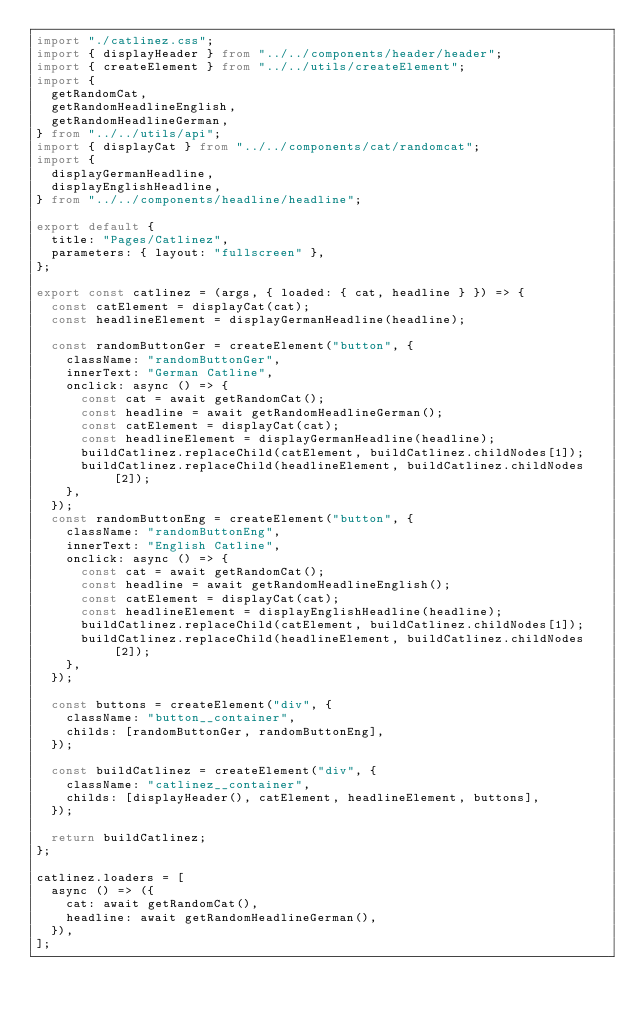Convert code to text. <code><loc_0><loc_0><loc_500><loc_500><_TypeScript_>import "./catlinez.css";
import { displayHeader } from "../../components/header/header";
import { createElement } from "../../utils/createElement";
import {
  getRandomCat,
  getRandomHeadlineEnglish,
  getRandomHeadlineGerman,
} from "../../utils/api";
import { displayCat } from "../../components/cat/randomcat";
import {
  displayGermanHeadline,
  displayEnglishHeadline,
} from "../../components/headline/headline";

export default {
  title: "Pages/Catlinez",
  parameters: { layout: "fullscreen" },
};

export const catlinez = (args, { loaded: { cat, headline } }) => {
  const catElement = displayCat(cat);
  const headlineElement = displayGermanHeadline(headline);

  const randomButtonGer = createElement("button", {
    className: "randomButtonGer",
    innerText: "German Catline",
    onclick: async () => {
      const cat = await getRandomCat();
      const headline = await getRandomHeadlineGerman();
      const catElement = displayCat(cat);
      const headlineElement = displayGermanHeadline(headline);
      buildCatlinez.replaceChild(catElement, buildCatlinez.childNodes[1]);
      buildCatlinez.replaceChild(headlineElement, buildCatlinez.childNodes[2]);
    },
  });
  const randomButtonEng = createElement("button", {
    className: "randomButtonEng",
    innerText: "English Catline",
    onclick: async () => {
      const cat = await getRandomCat();
      const headline = await getRandomHeadlineEnglish();
      const catElement = displayCat(cat);
      const headlineElement = displayEnglishHeadline(headline);
      buildCatlinez.replaceChild(catElement, buildCatlinez.childNodes[1]);
      buildCatlinez.replaceChild(headlineElement, buildCatlinez.childNodes[2]);
    },
  });

  const buttons = createElement("div", {
    className: "button__container",
    childs: [randomButtonGer, randomButtonEng],
  });

  const buildCatlinez = createElement("div", {
    className: "catlinez__container",
    childs: [displayHeader(), catElement, headlineElement, buttons],
  });

  return buildCatlinez;
};

catlinez.loaders = [
  async () => ({
    cat: await getRandomCat(),
    headline: await getRandomHeadlineGerman(),
  }),
];
</code> 